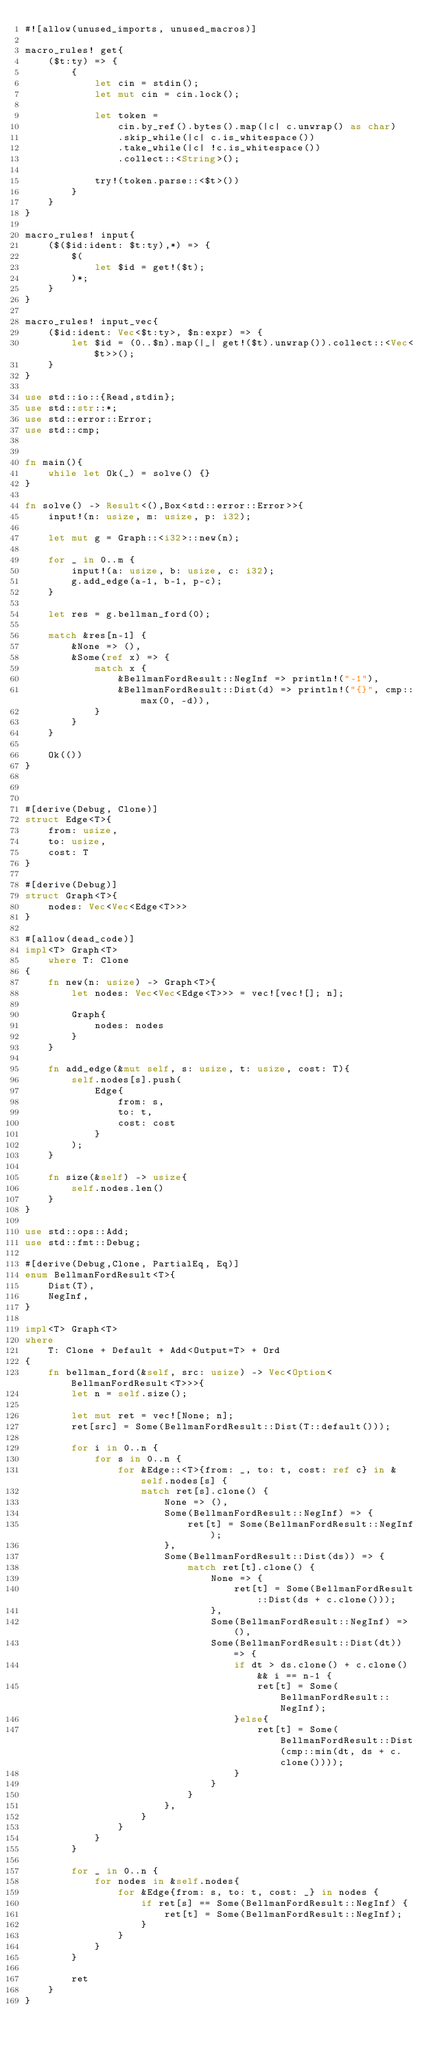Convert code to text. <code><loc_0><loc_0><loc_500><loc_500><_Rust_>#![allow(unused_imports, unused_macros)]

macro_rules! get{
    ($t:ty) => {
        {
            let cin = stdin();
            let mut cin = cin.lock();
            
            let token =
                cin.by_ref().bytes().map(|c| c.unwrap() as char)
                .skip_while(|c| c.is_whitespace())
                .take_while(|c| !c.is_whitespace())
                .collect::<String>();

            try!(token.parse::<$t>())
        }
    }
}

macro_rules! input{
    ($($id:ident: $t:ty),*) => {
        $(
            let $id = get!($t);
        )*;
    }
}

macro_rules! input_vec{
    ($id:ident: Vec<$t:ty>, $n:expr) => {
        let $id = (0..$n).map(|_| get!($t).unwrap()).collect::<Vec<$t>>();
    }
}

use std::io::{Read,stdin};
use std::str::*;
use std::error::Error;
use std::cmp;


fn main(){
    while let Ok(_) = solve() {}
}

fn solve() -> Result<(),Box<std::error::Error>>{
    input!(n: usize, m: usize, p: i32);
    
    let mut g = Graph::<i32>::new(n);

    for _ in 0..m {
        input!(a: usize, b: usize, c: i32);
        g.add_edge(a-1, b-1, p-c);
    }

    let res = g.bellman_ford(0);

    match &res[n-1] {
        &None => (),
        &Some(ref x) => {
            match x {
                &BellmanFordResult::NegInf => println!("-1"),
                &BellmanFordResult::Dist(d) => println!("{}", cmp::max(0, -d)),
            }
        }
    }
    
    Ok(())
}



#[derive(Debug, Clone)]
struct Edge<T>{
    from: usize,
    to: usize,
    cost: T
}

#[derive(Debug)]
struct Graph<T>{
    nodes: Vec<Vec<Edge<T>>>
}

#[allow(dead_code)]
impl<T> Graph<T>
    where T: Clone
{
    fn new(n: usize) -> Graph<T>{
        let nodes: Vec<Vec<Edge<T>>> = vec![vec![]; n];

        Graph{
            nodes: nodes
        }
    }

    fn add_edge(&mut self, s: usize, t: usize, cost: T){
        self.nodes[s].push(
            Edge{
                from: s,
                to: t,
                cost: cost
            }
        );
    }

    fn size(&self) -> usize{
        self.nodes.len()
    }
}

use std::ops::Add;
use std::fmt::Debug;

#[derive(Debug,Clone, PartialEq, Eq)]
enum BellmanFordResult<T>{
    Dist(T),
    NegInf,
}

impl<T> Graph<T>
where
    T: Clone + Default + Add<Output=T> + Ord
{
    fn bellman_ford(&self, src: usize) -> Vec<Option<BellmanFordResult<T>>>{
        let n = self.size();
        
        let mut ret = vec![None; n];
        ret[src] = Some(BellmanFordResult::Dist(T::default()));

        for i in 0..n {
            for s in 0..n {
                for &Edge::<T>{from: _, to: t, cost: ref c} in &self.nodes[s] {
                    match ret[s].clone() {
                        None => (),
                        Some(BellmanFordResult::NegInf) => {
                            ret[t] = Some(BellmanFordResult::NegInf);
                        },
                        Some(BellmanFordResult::Dist(ds)) => {
                            match ret[t].clone() {
                                None => {
                                    ret[t] = Some(BellmanFordResult::Dist(ds + c.clone()));
                                },
                                Some(BellmanFordResult::NegInf) => (),
                                Some(BellmanFordResult::Dist(dt)) => {
                                    if dt > ds.clone() + c.clone() && i == n-1 {
                                        ret[t] = Some(BellmanFordResult::NegInf);
                                    }else{
                                        ret[t] = Some(BellmanFordResult::Dist(cmp::min(dt, ds + c.clone())));
                                    }
                                }
                            }
                        },
                    }
                }
            }
        }

        for _ in 0..n {
            for nodes in &self.nodes{
                for &Edge{from: s, to: t, cost: _} in nodes {
                    if ret[s] == Some(BellmanFordResult::NegInf) {
                        ret[t] = Some(BellmanFordResult::NegInf);
                    }
                }
            }
        }
        
        ret
    }
}
</code> 